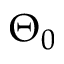<formula> <loc_0><loc_0><loc_500><loc_500>\Theta _ { 0 }</formula> 